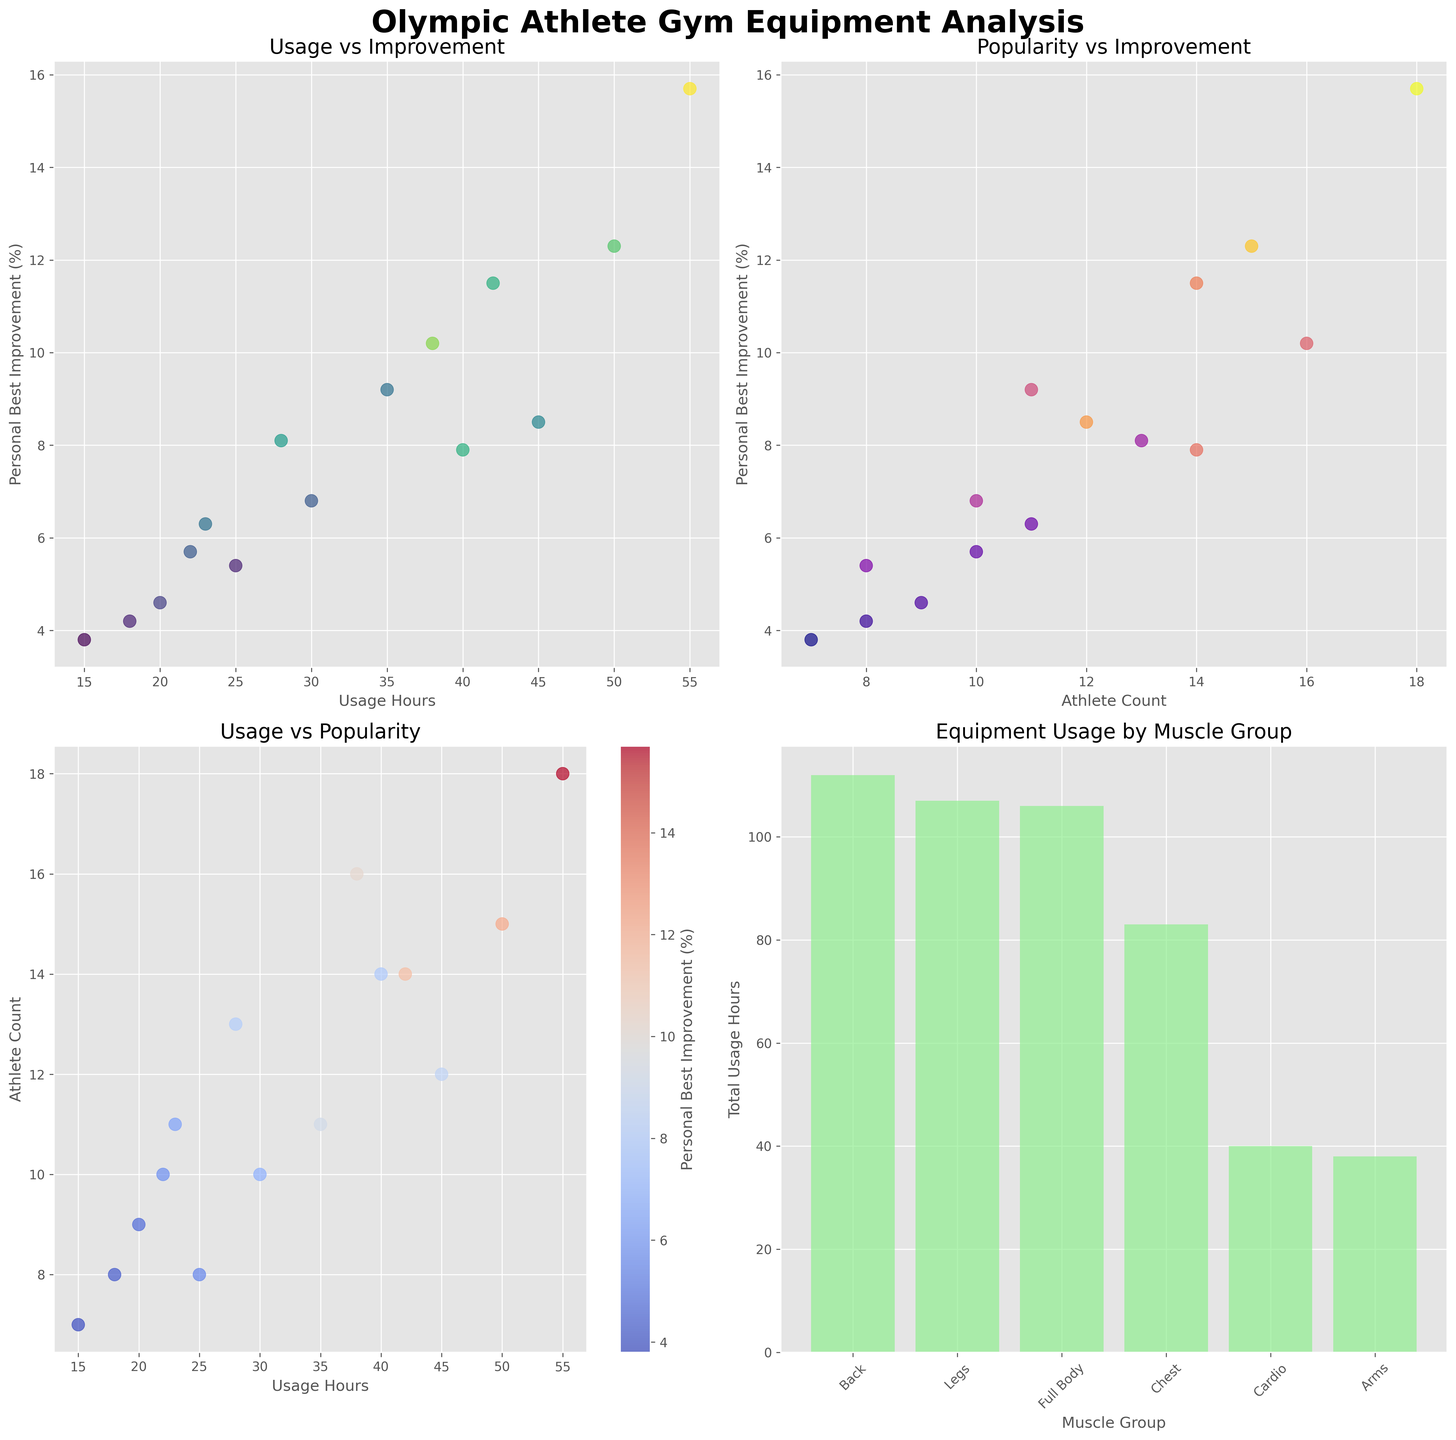How are the "Usage Hours" and "Personal Best Improvement" related among the athletes? By examining the first scatter plot (top-left subplot), the "Usage Hours" is on the x-axis and "Personal Best Improvement" is on the y-axis. Generally, as "Usage Hours" increase, "Personal Best Improvement" also increases, indicating a positive correlation.
Answer: Positively correlated Which piece of equipment shows the highest "Usage Hours" among the athletes? By looking at all the scatter plots, specifically the Equipment associated with the highest value on the x-axis for "Usage Hours", one can observe that the "Olympic Weightlifting Platform" has the highest "Usage Hours" of 55 hours.
Answer: Olympic Weightlifting Platform Which muscle group has the highest total equipment usage hours? In the bar plot (bottom-right subplot), the muscle group with the highest bar indicates the most total usage hours. "Legs" is the muscle group with the highest total equipment usage hours among the athletes.
Answer: Legs Which equipment has the fewest athletes using it? By examining the scatter plot of "Usage Hours vs Athlete Count" (bottom-left subplot), look for the equipment with the lowest value on the y-axis for "Athlete Count". The "Pull-Up Bar" is used by the fewest athletes with only 7 athletes.
Answer: Pull-Up Bar What are the total usage hours for all chest-related equipment? From the bar plot (bottom-right subplot) and considering each type of equipment for the "Chest" muscle group, add their usage hours: Barbell Bench Press (45) + Cable Crossover Machine (20) + Pec Deck Machine (18), which totals to 83 hours.
Answer: 83 hours Which equipment is associated with the highest personal best improvement, and what is the athlete count for it? By checking the scatter plot on Usage Hours vs Personal Best Improvement and identifying the highest y-value for "Personal Best Improvement", the "Olympic Weightlifting Platform" has the highest improvement of 15.7%, with an athlete count of 18.
Answer: Olympic Weightlifting Platform, 18 athletes How does the "Athlete Count" relate to "Personal Best Improvement"? In the scatter plot titled "Popularity vs Improvement" (top-right subplot), the x-axis represents "Athlete Count" and the y-axis shows "Personal Best Improvement". The observations suggest a positive trend: as "Athlete Count" increases, "Personal Best Improvement" generally increases.
Answer: Positively correlated Which equipment targets the arms and what is its usage hours? In the equipment list provided, the "Dumbbells" are associated with the "Arms" muscle group, and its usage hours are 38 hours.
Answer: Dumbbells, 38 Compare the total usage hours of equipment targeting the "Full Body" with that targeting the "Back". Which has more usage hours? Sum the usage hours from the bottom-right subplot for "Full Body" (Olympic Weightlifting Platform: 55, Kettlebells: 28, Battle Ropes: 23) which totals to 106 hours. For "Back" (Lat Pulldown Machine: 30, Rowing Machine: 25, Pull-Up Bar: 15, Deadlift Platform: 42), the total is 112 hours. The "Back" muscle group has more usage hours.
Answer: Back Which piece of equipment has the highest athlete count and how much is that count? By examining the scatter plots, specifically look for the highest y-value in the "Usage Hours vs Athlete Count" scatter plot (bottom-left subplot). The "Olympic Weightlifting Platform" has the highest athlete count of 18.
Answer: Olympic Weightlifting Platform, 18 